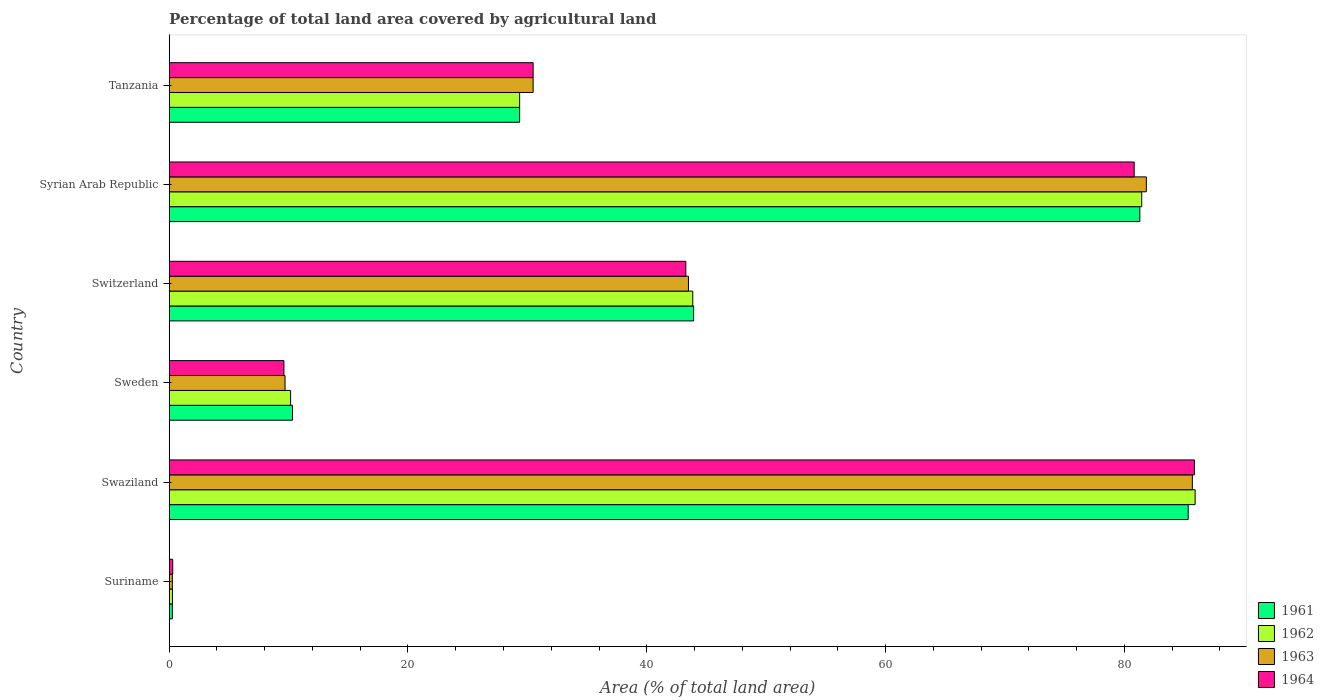How many groups of bars are there?
Make the answer very short. 6. Are the number of bars per tick equal to the number of legend labels?
Give a very brief answer. Yes. Are the number of bars on each tick of the Y-axis equal?
Keep it short and to the point. Yes. How many bars are there on the 4th tick from the bottom?
Your answer should be compact. 4. What is the label of the 6th group of bars from the top?
Make the answer very short. Suriname. In how many cases, is the number of bars for a given country not equal to the number of legend labels?
Provide a short and direct response. 0. What is the percentage of agricultural land in 1963 in Switzerland?
Provide a succinct answer. 43.49. Across all countries, what is the maximum percentage of agricultural land in 1964?
Offer a very short reply. 85.87. Across all countries, what is the minimum percentage of agricultural land in 1962?
Keep it short and to the point. 0.27. In which country was the percentage of agricultural land in 1964 maximum?
Offer a terse response. Swaziland. In which country was the percentage of agricultural land in 1963 minimum?
Give a very brief answer. Suriname. What is the total percentage of agricultural land in 1962 in the graph?
Keep it short and to the point. 251.03. What is the difference between the percentage of agricultural land in 1962 in Suriname and that in Switzerland?
Keep it short and to the point. -43.58. What is the difference between the percentage of agricultural land in 1961 in Tanzania and the percentage of agricultural land in 1964 in Swaziland?
Keep it short and to the point. -56.52. What is the average percentage of agricultural land in 1962 per country?
Provide a succinct answer. 41.84. What is the difference between the percentage of agricultural land in 1961 and percentage of agricultural land in 1963 in Syrian Arab Republic?
Your answer should be very brief. -0.54. In how many countries, is the percentage of agricultural land in 1964 greater than 60 %?
Your answer should be compact. 2. What is the ratio of the percentage of agricultural land in 1963 in Syrian Arab Republic to that in Tanzania?
Your response must be concise. 2.69. What is the difference between the highest and the second highest percentage of agricultural land in 1963?
Ensure brevity in your answer.  3.86. What is the difference between the highest and the lowest percentage of agricultural land in 1963?
Your answer should be very brief. 85.43. In how many countries, is the percentage of agricultural land in 1962 greater than the average percentage of agricultural land in 1962 taken over all countries?
Provide a succinct answer. 3. Is the sum of the percentage of agricultural land in 1964 in Suriname and Swaziland greater than the maximum percentage of agricultural land in 1961 across all countries?
Provide a succinct answer. Yes. What does the 4th bar from the bottom in Swaziland represents?
Make the answer very short. 1964. Are all the bars in the graph horizontal?
Your response must be concise. Yes. How many countries are there in the graph?
Keep it short and to the point. 6. Does the graph contain grids?
Provide a short and direct response. No. Where does the legend appear in the graph?
Make the answer very short. Bottom right. How are the legend labels stacked?
Offer a terse response. Vertical. What is the title of the graph?
Provide a succinct answer. Percentage of total land area covered by agricultural land. Does "1998" appear as one of the legend labels in the graph?
Provide a succinct answer. No. What is the label or title of the X-axis?
Your answer should be very brief. Area (% of total land area). What is the Area (% of total land area) of 1961 in Suriname?
Your response must be concise. 0.26. What is the Area (% of total land area) in 1962 in Suriname?
Offer a very short reply. 0.27. What is the Area (% of total land area) in 1963 in Suriname?
Provide a succinct answer. 0.26. What is the Area (% of total land area) in 1964 in Suriname?
Provide a short and direct response. 0.29. What is the Area (% of total land area) of 1961 in Swaziland?
Make the answer very short. 85.35. What is the Area (% of total land area) of 1962 in Swaziland?
Your answer should be compact. 85.93. What is the Area (% of total land area) in 1963 in Swaziland?
Keep it short and to the point. 85.7. What is the Area (% of total land area) in 1964 in Swaziland?
Provide a succinct answer. 85.87. What is the Area (% of total land area) in 1961 in Sweden?
Your answer should be compact. 10.33. What is the Area (% of total land area) of 1962 in Sweden?
Make the answer very short. 10.17. What is the Area (% of total land area) in 1963 in Sweden?
Offer a terse response. 9.7. What is the Area (% of total land area) in 1964 in Sweden?
Offer a very short reply. 9.61. What is the Area (% of total land area) in 1961 in Switzerland?
Your answer should be very brief. 43.93. What is the Area (% of total land area) in 1962 in Switzerland?
Your answer should be compact. 43.85. What is the Area (% of total land area) in 1963 in Switzerland?
Give a very brief answer. 43.49. What is the Area (% of total land area) of 1964 in Switzerland?
Make the answer very short. 43.27. What is the Area (% of total land area) of 1961 in Syrian Arab Republic?
Offer a very short reply. 81.3. What is the Area (% of total land area) in 1962 in Syrian Arab Republic?
Make the answer very short. 81.46. What is the Area (% of total land area) in 1963 in Syrian Arab Republic?
Give a very brief answer. 81.84. What is the Area (% of total land area) of 1964 in Syrian Arab Republic?
Your answer should be compact. 80.82. What is the Area (% of total land area) in 1961 in Tanzania?
Make the answer very short. 29.35. What is the Area (% of total land area) in 1962 in Tanzania?
Provide a short and direct response. 29.35. What is the Area (% of total land area) in 1963 in Tanzania?
Offer a very short reply. 30.48. What is the Area (% of total land area) in 1964 in Tanzania?
Provide a succinct answer. 30.48. Across all countries, what is the maximum Area (% of total land area) in 1961?
Provide a short and direct response. 85.35. Across all countries, what is the maximum Area (% of total land area) of 1962?
Provide a short and direct response. 85.93. Across all countries, what is the maximum Area (% of total land area) in 1963?
Your answer should be compact. 85.7. Across all countries, what is the maximum Area (% of total land area) of 1964?
Your answer should be compact. 85.87. Across all countries, what is the minimum Area (% of total land area) of 1961?
Your answer should be very brief. 0.26. Across all countries, what is the minimum Area (% of total land area) of 1962?
Offer a very short reply. 0.27. Across all countries, what is the minimum Area (% of total land area) of 1963?
Your response must be concise. 0.26. Across all countries, what is the minimum Area (% of total land area) of 1964?
Ensure brevity in your answer.  0.29. What is the total Area (% of total land area) of 1961 in the graph?
Provide a short and direct response. 250.51. What is the total Area (% of total land area) in 1962 in the graph?
Offer a very short reply. 251.03. What is the total Area (% of total land area) in 1963 in the graph?
Ensure brevity in your answer.  251.48. What is the total Area (% of total land area) in 1964 in the graph?
Keep it short and to the point. 250.35. What is the difference between the Area (% of total land area) of 1961 in Suriname and that in Swaziland?
Keep it short and to the point. -85.09. What is the difference between the Area (% of total land area) in 1962 in Suriname and that in Swaziland?
Offer a very short reply. -85.66. What is the difference between the Area (% of total land area) in 1963 in Suriname and that in Swaziland?
Your answer should be very brief. -85.43. What is the difference between the Area (% of total land area) in 1964 in Suriname and that in Swaziland?
Give a very brief answer. -85.58. What is the difference between the Area (% of total land area) in 1961 in Suriname and that in Sweden?
Your answer should be very brief. -10.06. What is the difference between the Area (% of total land area) in 1962 in Suriname and that in Sweden?
Your response must be concise. -9.9. What is the difference between the Area (% of total land area) of 1963 in Suriname and that in Sweden?
Keep it short and to the point. -9.44. What is the difference between the Area (% of total land area) in 1964 in Suriname and that in Sweden?
Your response must be concise. -9.31. What is the difference between the Area (% of total land area) in 1961 in Suriname and that in Switzerland?
Your answer should be compact. -43.66. What is the difference between the Area (% of total land area) in 1962 in Suriname and that in Switzerland?
Provide a short and direct response. -43.58. What is the difference between the Area (% of total land area) of 1963 in Suriname and that in Switzerland?
Your response must be concise. -43.23. What is the difference between the Area (% of total land area) of 1964 in Suriname and that in Switzerland?
Offer a very short reply. -42.98. What is the difference between the Area (% of total land area) of 1961 in Suriname and that in Syrian Arab Republic?
Keep it short and to the point. -81.04. What is the difference between the Area (% of total land area) in 1962 in Suriname and that in Syrian Arab Republic?
Your answer should be compact. -81.19. What is the difference between the Area (% of total land area) in 1963 in Suriname and that in Syrian Arab Republic?
Your answer should be compact. -81.58. What is the difference between the Area (% of total land area) in 1964 in Suriname and that in Syrian Arab Republic?
Offer a very short reply. -80.53. What is the difference between the Area (% of total land area) in 1961 in Suriname and that in Tanzania?
Offer a terse response. -29.09. What is the difference between the Area (% of total land area) of 1962 in Suriname and that in Tanzania?
Provide a succinct answer. -29.08. What is the difference between the Area (% of total land area) of 1963 in Suriname and that in Tanzania?
Your answer should be very brief. -30.22. What is the difference between the Area (% of total land area) of 1964 in Suriname and that in Tanzania?
Ensure brevity in your answer.  -30.19. What is the difference between the Area (% of total land area) in 1961 in Swaziland and that in Sweden?
Keep it short and to the point. 75.02. What is the difference between the Area (% of total land area) in 1962 in Swaziland and that in Sweden?
Provide a succinct answer. 75.76. What is the difference between the Area (% of total land area) in 1963 in Swaziland and that in Sweden?
Make the answer very short. 76. What is the difference between the Area (% of total land area) in 1964 in Swaziland and that in Sweden?
Keep it short and to the point. 76.26. What is the difference between the Area (% of total land area) in 1961 in Swaziland and that in Switzerland?
Provide a short and direct response. 41.42. What is the difference between the Area (% of total land area) of 1962 in Swaziland and that in Switzerland?
Your answer should be very brief. 42.08. What is the difference between the Area (% of total land area) of 1963 in Swaziland and that in Switzerland?
Give a very brief answer. 42.2. What is the difference between the Area (% of total land area) of 1964 in Swaziland and that in Switzerland?
Provide a short and direct response. 42.6. What is the difference between the Area (% of total land area) in 1961 in Swaziland and that in Syrian Arab Republic?
Make the answer very short. 4.05. What is the difference between the Area (% of total land area) of 1962 in Swaziland and that in Syrian Arab Republic?
Offer a very short reply. 4.47. What is the difference between the Area (% of total land area) of 1963 in Swaziland and that in Syrian Arab Republic?
Provide a succinct answer. 3.86. What is the difference between the Area (% of total land area) in 1964 in Swaziland and that in Syrian Arab Republic?
Offer a very short reply. 5.05. What is the difference between the Area (% of total land area) in 1961 in Swaziland and that in Tanzania?
Provide a short and direct response. 56. What is the difference between the Area (% of total land area) of 1962 in Swaziland and that in Tanzania?
Provide a succinct answer. 56.58. What is the difference between the Area (% of total land area) in 1963 in Swaziland and that in Tanzania?
Your answer should be very brief. 55.22. What is the difference between the Area (% of total land area) of 1964 in Swaziland and that in Tanzania?
Make the answer very short. 55.39. What is the difference between the Area (% of total land area) in 1961 in Sweden and that in Switzerland?
Your answer should be very brief. -33.6. What is the difference between the Area (% of total land area) of 1962 in Sweden and that in Switzerland?
Your response must be concise. -33.69. What is the difference between the Area (% of total land area) in 1963 in Sweden and that in Switzerland?
Provide a succinct answer. -33.79. What is the difference between the Area (% of total land area) of 1964 in Sweden and that in Switzerland?
Make the answer very short. -33.66. What is the difference between the Area (% of total land area) of 1961 in Sweden and that in Syrian Arab Republic?
Give a very brief answer. -70.97. What is the difference between the Area (% of total land area) in 1962 in Sweden and that in Syrian Arab Republic?
Your answer should be compact. -71.29. What is the difference between the Area (% of total land area) of 1963 in Sweden and that in Syrian Arab Republic?
Your response must be concise. -72.14. What is the difference between the Area (% of total land area) of 1964 in Sweden and that in Syrian Arab Republic?
Provide a short and direct response. -71.22. What is the difference between the Area (% of total land area) in 1961 in Sweden and that in Tanzania?
Your answer should be compact. -19.03. What is the difference between the Area (% of total land area) in 1962 in Sweden and that in Tanzania?
Your answer should be very brief. -19.18. What is the difference between the Area (% of total land area) in 1963 in Sweden and that in Tanzania?
Give a very brief answer. -20.78. What is the difference between the Area (% of total land area) in 1964 in Sweden and that in Tanzania?
Your response must be concise. -20.87. What is the difference between the Area (% of total land area) of 1961 in Switzerland and that in Syrian Arab Republic?
Your answer should be compact. -37.37. What is the difference between the Area (% of total land area) in 1962 in Switzerland and that in Syrian Arab Republic?
Give a very brief answer. -37.6. What is the difference between the Area (% of total land area) of 1963 in Switzerland and that in Syrian Arab Republic?
Make the answer very short. -38.35. What is the difference between the Area (% of total land area) in 1964 in Switzerland and that in Syrian Arab Republic?
Provide a short and direct response. -37.55. What is the difference between the Area (% of total land area) in 1961 in Switzerland and that in Tanzania?
Give a very brief answer. 14.57. What is the difference between the Area (% of total land area) of 1962 in Switzerland and that in Tanzania?
Offer a terse response. 14.5. What is the difference between the Area (% of total land area) in 1963 in Switzerland and that in Tanzania?
Offer a very short reply. 13.01. What is the difference between the Area (% of total land area) in 1964 in Switzerland and that in Tanzania?
Make the answer very short. 12.79. What is the difference between the Area (% of total land area) in 1961 in Syrian Arab Republic and that in Tanzania?
Your answer should be very brief. 51.95. What is the difference between the Area (% of total land area) of 1962 in Syrian Arab Republic and that in Tanzania?
Ensure brevity in your answer.  52.1. What is the difference between the Area (% of total land area) in 1963 in Syrian Arab Republic and that in Tanzania?
Provide a short and direct response. 51.36. What is the difference between the Area (% of total land area) of 1964 in Syrian Arab Republic and that in Tanzania?
Ensure brevity in your answer.  50.34. What is the difference between the Area (% of total land area) of 1961 in Suriname and the Area (% of total land area) of 1962 in Swaziland?
Give a very brief answer. -85.67. What is the difference between the Area (% of total land area) in 1961 in Suriname and the Area (% of total land area) in 1963 in Swaziland?
Your response must be concise. -85.43. What is the difference between the Area (% of total land area) in 1961 in Suriname and the Area (% of total land area) in 1964 in Swaziland?
Your answer should be very brief. -85.61. What is the difference between the Area (% of total land area) in 1962 in Suriname and the Area (% of total land area) in 1963 in Swaziland?
Offer a very short reply. -85.43. What is the difference between the Area (% of total land area) in 1962 in Suriname and the Area (% of total land area) in 1964 in Swaziland?
Provide a short and direct response. -85.6. What is the difference between the Area (% of total land area) in 1963 in Suriname and the Area (% of total land area) in 1964 in Swaziland?
Your response must be concise. -85.61. What is the difference between the Area (% of total land area) of 1961 in Suriname and the Area (% of total land area) of 1962 in Sweden?
Your answer should be very brief. -9.9. What is the difference between the Area (% of total land area) in 1961 in Suriname and the Area (% of total land area) in 1963 in Sweden?
Give a very brief answer. -9.44. What is the difference between the Area (% of total land area) in 1961 in Suriname and the Area (% of total land area) in 1964 in Sweden?
Offer a terse response. -9.35. What is the difference between the Area (% of total land area) in 1962 in Suriname and the Area (% of total land area) in 1963 in Sweden?
Make the answer very short. -9.43. What is the difference between the Area (% of total land area) in 1962 in Suriname and the Area (% of total land area) in 1964 in Sweden?
Your answer should be compact. -9.34. What is the difference between the Area (% of total land area) of 1963 in Suriname and the Area (% of total land area) of 1964 in Sweden?
Make the answer very short. -9.35. What is the difference between the Area (% of total land area) of 1961 in Suriname and the Area (% of total land area) of 1962 in Switzerland?
Provide a succinct answer. -43.59. What is the difference between the Area (% of total land area) of 1961 in Suriname and the Area (% of total land area) of 1963 in Switzerland?
Make the answer very short. -43.23. What is the difference between the Area (% of total land area) in 1961 in Suriname and the Area (% of total land area) in 1964 in Switzerland?
Your answer should be very brief. -43.01. What is the difference between the Area (% of total land area) in 1962 in Suriname and the Area (% of total land area) in 1963 in Switzerland?
Provide a succinct answer. -43.22. What is the difference between the Area (% of total land area) of 1962 in Suriname and the Area (% of total land area) of 1964 in Switzerland?
Offer a terse response. -43. What is the difference between the Area (% of total land area) in 1963 in Suriname and the Area (% of total land area) in 1964 in Switzerland?
Provide a succinct answer. -43.01. What is the difference between the Area (% of total land area) in 1961 in Suriname and the Area (% of total land area) in 1962 in Syrian Arab Republic?
Provide a succinct answer. -81.19. What is the difference between the Area (% of total land area) of 1961 in Suriname and the Area (% of total land area) of 1963 in Syrian Arab Republic?
Your answer should be very brief. -81.58. What is the difference between the Area (% of total land area) in 1961 in Suriname and the Area (% of total land area) in 1964 in Syrian Arab Republic?
Your response must be concise. -80.56. What is the difference between the Area (% of total land area) of 1962 in Suriname and the Area (% of total land area) of 1963 in Syrian Arab Republic?
Your answer should be very brief. -81.57. What is the difference between the Area (% of total land area) in 1962 in Suriname and the Area (% of total land area) in 1964 in Syrian Arab Republic?
Your answer should be very brief. -80.56. What is the difference between the Area (% of total land area) in 1963 in Suriname and the Area (% of total land area) in 1964 in Syrian Arab Republic?
Your response must be concise. -80.56. What is the difference between the Area (% of total land area) in 1961 in Suriname and the Area (% of total land area) in 1962 in Tanzania?
Provide a succinct answer. -29.09. What is the difference between the Area (% of total land area) of 1961 in Suriname and the Area (% of total land area) of 1963 in Tanzania?
Make the answer very short. -30.22. What is the difference between the Area (% of total land area) in 1961 in Suriname and the Area (% of total land area) in 1964 in Tanzania?
Give a very brief answer. -30.22. What is the difference between the Area (% of total land area) in 1962 in Suriname and the Area (% of total land area) in 1963 in Tanzania?
Offer a very short reply. -30.21. What is the difference between the Area (% of total land area) of 1962 in Suriname and the Area (% of total land area) of 1964 in Tanzania?
Keep it short and to the point. -30.21. What is the difference between the Area (% of total land area) in 1963 in Suriname and the Area (% of total land area) in 1964 in Tanzania?
Ensure brevity in your answer.  -30.22. What is the difference between the Area (% of total land area) in 1961 in Swaziland and the Area (% of total land area) in 1962 in Sweden?
Your response must be concise. 75.18. What is the difference between the Area (% of total land area) of 1961 in Swaziland and the Area (% of total land area) of 1963 in Sweden?
Keep it short and to the point. 75.65. What is the difference between the Area (% of total land area) of 1961 in Swaziland and the Area (% of total land area) of 1964 in Sweden?
Provide a succinct answer. 75.74. What is the difference between the Area (% of total land area) in 1962 in Swaziland and the Area (% of total land area) in 1963 in Sweden?
Provide a succinct answer. 76.23. What is the difference between the Area (% of total land area) of 1962 in Swaziland and the Area (% of total land area) of 1964 in Sweden?
Your answer should be very brief. 76.32. What is the difference between the Area (% of total land area) in 1963 in Swaziland and the Area (% of total land area) in 1964 in Sweden?
Your response must be concise. 76.09. What is the difference between the Area (% of total land area) of 1961 in Swaziland and the Area (% of total land area) of 1962 in Switzerland?
Your response must be concise. 41.5. What is the difference between the Area (% of total land area) in 1961 in Swaziland and the Area (% of total land area) in 1963 in Switzerland?
Make the answer very short. 41.86. What is the difference between the Area (% of total land area) of 1961 in Swaziland and the Area (% of total land area) of 1964 in Switzerland?
Make the answer very short. 42.08. What is the difference between the Area (% of total land area) of 1962 in Swaziland and the Area (% of total land area) of 1963 in Switzerland?
Your answer should be very brief. 42.44. What is the difference between the Area (% of total land area) in 1962 in Swaziland and the Area (% of total land area) in 1964 in Switzerland?
Your response must be concise. 42.66. What is the difference between the Area (% of total land area) of 1963 in Swaziland and the Area (% of total land area) of 1964 in Switzerland?
Your answer should be very brief. 42.43. What is the difference between the Area (% of total land area) in 1961 in Swaziland and the Area (% of total land area) in 1962 in Syrian Arab Republic?
Your answer should be compact. 3.89. What is the difference between the Area (% of total land area) in 1961 in Swaziland and the Area (% of total land area) in 1963 in Syrian Arab Republic?
Ensure brevity in your answer.  3.51. What is the difference between the Area (% of total land area) in 1961 in Swaziland and the Area (% of total land area) in 1964 in Syrian Arab Republic?
Provide a short and direct response. 4.52. What is the difference between the Area (% of total land area) in 1962 in Swaziland and the Area (% of total land area) in 1963 in Syrian Arab Republic?
Your response must be concise. 4.09. What is the difference between the Area (% of total land area) of 1962 in Swaziland and the Area (% of total land area) of 1964 in Syrian Arab Republic?
Keep it short and to the point. 5.11. What is the difference between the Area (% of total land area) of 1963 in Swaziland and the Area (% of total land area) of 1964 in Syrian Arab Republic?
Offer a very short reply. 4.87. What is the difference between the Area (% of total land area) in 1961 in Swaziland and the Area (% of total land area) in 1962 in Tanzania?
Make the answer very short. 56. What is the difference between the Area (% of total land area) in 1961 in Swaziland and the Area (% of total land area) in 1963 in Tanzania?
Your answer should be compact. 54.87. What is the difference between the Area (% of total land area) of 1961 in Swaziland and the Area (% of total land area) of 1964 in Tanzania?
Keep it short and to the point. 54.87. What is the difference between the Area (% of total land area) of 1962 in Swaziland and the Area (% of total land area) of 1963 in Tanzania?
Your response must be concise. 55.45. What is the difference between the Area (% of total land area) in 1962 in Swaziland and the Area (% of total land area) in 1964 in Tanzania?
Ensure brevity in your answer.  55.45. What is the difference between the Area (% of total land area) in 1963 in Swaziland and the Area (% of total land area) in 1964 in Tanzania?
Make the answer very short. 55.22. What is the difference between the Area (% of total land area) in 1961 in Sweden and the Area (% of total land area) in 1962 in Switzerland?
Keep it short and to the point. -33.53. What is the difference between the Area (% of total land area) in 1961 in Sweden and the Area (% of total land area) in 1963 in Switzerland?
Give a very brief answer. -33.17. What is the difference between the Area (% of total land area) of 1961 in Sweden and the Area (% of total land area) of 1964 in Switzerland?
Offer a very short reply. -32.95. What is the difference between the Area (% of total land area) of 1962 in Sweden and the Area (% of total land area) of 1963 in Switzerland?
Your response must be concise. -33.33. What is the difference between the Area (% of total land area) in 1962 in Sweden and the Area (% of total land area) in 1964 in Switzerland?
Keep it short and to the point. -33.1. What is the difference between the Area (% of total land area) of 1963 in Sweden and the Area (% of total land area) of 1964 in Switzerland?
Keep it short and to the point. -33.57. What is the difference between the Area (% of total land area) of 1961 in Sweden and the Area (% of total land area) of 1962 in Syrian Arab Republic?
Offer a terse response. -71.13. What is the difference between the Area (% of total land area) in 1961 in Sweden and the Area (% of total land area) in 1963 in Syrian Arab Republic?
Ensure brevity in your answer.  -71.52. What is the difference between the Area (% of total land area) of 1961 in Sweden and the Area (% of total land area) of 1964 in Syrian Arab Republic?
Provide a succinct answer. -70.5. What is the difference between the Area (% of total land area) of 1962 in Sweden and the Area (% of total land area) of 1963 in Syrian Arab Republic?
Give a very brief answer. -71.68. What is the difference between the Area (% of total land area) in 1962 in Sweden and the Area (% of total land area) in 1964 in Syrian Arab Republic?
Your answer should be compact. -70.66. What is the difference between the Area (% of total land area) of 1963 in Sweden and the Area (% of total land area) of 1964 in Syrian Arab Republic?
Your response must be concise. -71.12. What is the difference between the Area (% of total land area) of 1961 in Sweden and the Area (% of total land area) of 1962 in Tanzania?
Your answer should be very brief. -19.03. What is the difference between the Area (% of total land area) in 1961 in Sweden and the Area (% of total land area) in 1963 in Tanzania?
Give a very brief answer. -20.16. What is the difference between the Area (% of total land area) of 1961 in Sweden and the Area (% of total land area) of 1964 in Tanzania?
Provide a short and direct response. -20.16. What is the difference between the Area (% of total land area) in 1962 in Sweden and the Area (% of total land area) in 1963 in Tanzania?
Provide a succinct answer. -20.31. What is the difference between the Area (% of total land area) in 1962 in Sweden and the Area (% of total land area) in 1964 in Tanzania?
Your answer should be compact. -20.31. What is the difference between the Area (% of total land area) of 1963 in Sweden and the Area (% of total land area) of 1964 in Tanzania?
Make the answer very short. -20.78. What is the difference between the Area (% of total land area) of 1961 in Switzerland and the Area (% of total land area) of 1962 in Syrian Arab Republic?
Ensure brevity in your answer.  -37.53. What is the difference between the Area (% of total land area) of 1961 in Switzerland and the Area (% of total land area) of 1963 in Syrian Arab Republic?
Ensure brevity in your answer.  -37.92. What is the difference between the Area (% of total land area) of 1961 in Switzerland and the Area (% of total land area) of 1964 in Syrian Arab Republic?
Provide a short and direct response. -36.9. What is the difference between the Area (% of total land area) of 1962 in Switzerland and the Area (% of total land area) of 1963 in Syrian Arab Republic?
Make the answer very short. -37.99. What is the difference between the Area (% of total land area) in 1962 in Switzerland and the Area (% of total land area) in 1964 in Syrian Arab Republic?
Give a very brief answer. -36.97. What is the difference between the Area (% of total land area) in 1963 in Switzerland and the Area (% of total land area) in 1964 in Syrian Arab Republic?
Keep it short and to the point. -37.33. What is the difference between the Area (% of total land area) of 1961 in Switzerland and the Area (% of total land area) of 1962 in Tanzania?
Make the answer very short. 14.57. What is the difference between the Area (% of total land area) in 1961 in Switzerland and the Area (% of total land area) in 1963 in Tanzania?
Your response must be concise. 13.44. What is the difference between the Area (% of total land area) in 1961 in Switzerland and the Area (% of total land area) in 1964 in Tanzania?
Your answer should be compact. 13.44. What is the difference between the Area (% of total land area) in 1962 in Switzerland and the Area (% of total land area) in 1963 in Tanzania?
Give a very brief answer. 13.37. What is the difference between the Area (% of total land area) of 1962 in Switzerland and the Area (% of total land area) of 1964 in Tanzania?
Provide a short and direct response. 13.37. What is the difference between the Area (% of total land area) in 1963 in Switzerland and the Area (% of total land area) in 1964 in Tanzania?
Your answer should be compact. 13.01. What is the difference between the Area (% of total land area) in 1961 in Syrian Arab Republic and the Area (% of total land area) in 1962 in Tanzania?
Offer a very short reply. 51.95. What is the difference between the Area (% of total land area) of 1961 in Syrian Arab Republic and the Area (% of total land area) of 1963 in Tanzania?
Your answer should be compact. 50.82. What is the difference between the Area (% of total land area) of 1961 in Syrian Arab Republic and the Area (% of total land area) of 1964 in Tanzania?
Your response must be concise. 50.82. What is the difference between the Area (% of total land area) of 1962 in Syrian Arab Republic and the Area (% of total land area) of 1963 in Tanzania?
Your answer should be very brief. 50.98. What is the difference between the Area (% of total land area) of 1962 in Syrian Arab Republic and the Area (% of total land area) of 1964 in Tanzania?
Ensure brevity in your answer.  50.98. What is the difference between the Area (% of total land area) in 1963 in Syrian Arab Republic and the Area (% of total land area) in 1964 in Tanzania?
Give a very brief answer. 51.36. What is the average Area (% of total land area) of 1961 per country?
Offer a terse response. 41.75. What is the average Area (% of total land area) of 1962 per country?
Provide a succinct answer. 41.84. What is the average Area (% of total land area) of 1963 per country?
Offer a very short reply. 41.91. What is the average Area (% of total land area) in 1964 per country?
Offer a very short reply. 41.73. What is the difference between the Area (% of total land area) in 1961 and Area (% of total land area) in 1962 in Suriname?
Your answer should be compact. -0.01. What is the difference between the Area (% of total land area) in 1961 and Area (% of total land area) in 1963 in Suriname?
Offer a very short reply. 0. What is the difference between the Area (% of total land area) of 1961 and Area (% of total land area) of 1964 in Suriname?
Offer a terse response. -0.03. What is the difference between the Area (% of total land area) of 1962 and Area (% of total land area) of 1963 in Suriname?
Your answer should be very brief. 0.01. What is the difference between the Area (% of total land area) in 1962 and Area (% of total land area) in 1964 in Suriname?
Provide a short and direct response. -0.03. What is the difference between the Area (% of total land area) in 1963 and Area (% of total land area) in 1964 in Suriname?
Offer a very short reply. -0.03. What is the difference between the Area (% of total land area) of 1961 and Area (% of total land area) of 1962 in Swaziland?
Make the answer very short. -0.58. What is the difference between the Area (% of total land area) in 1961 and Area (% of total land area) in 1963 in Swaziland?
Provide a short and direct response. -0.35. What is the difference between the Area (% of total land area) of 1961 and Area (% of total land area) of 1964 in Swaziland?
Make the answer very short. -0.52. What is the difference between the Area (% of total land area) of 1962 and Area (% of total land area) of 1963 in Swaziland?
Keep it short and to the point. 0.23. What is the difference between the Area (% of total land area) in 1962 and Area (% of total land area) in 1964 in Swaziland?
Ensure brevity in your answer.  0.06. What is the difference between the Area (% of total land area) of 1963 and Area (% of total land area) of 1964 in Swaziland?
Ensure brevity in your answer.  -0.17. What is the difference between the Area (% of total land area) of 1961 and Area (% of total land area) of 1962 in Sweden?
Ensure brevity in your answer.  0.16. What is the difference between the Area (% of total land area) in 1961 and Area (% of total land area) in 1963 in Sweden?
Offer a terse response. 0.62. What is the difference between the Area (% of total land area) of 1961 and Area (% of total land area) of 1964 in Sweden?
Your response must be concise. 0.72. What is the difference between the Area (% of total land area) in 1962 and Area (% of total land area) in 1963 in Sweden?
Your answer should be compact. 0.47. What is the difference between the Area (% of total land area) of 1962 and Area (% of total land area) of 1964 in Sweden?
Ensure brevity in your answer.  0.56. What is the difference between the Area (% of total land area) in 1963 and Area (% of total land area) in 1964 in Sweden?
Make the answer very short. 0.09. What is the difference between the Area (% of total land area) of 1961 and Area (% of total land area) of 1962 in Switzerland?
Make the answer very short. 0.07. What is the difference between the Area (% of total land area) in 1961 and Area (% of total land area) in 1963 in Switzerland?
Offer a terse response. 0.43. What is the difference between the Area (% of total land area) of 1961 and Area (% of total land area) of 1964 in Switzerland?
Provide a short and direct response. 0.66. What is the difference between the Area (% of total land area) of 1962 and Area (% of total land area) of 1963 in Switzerland?
Your answer should be very brief. 0.36. What is the difference between the Area (% of total land area) in 1962 and Area (% of total land area) in 1964 in Switzerland?
Your answer should be compact. 0.58. What is the difference between the Area (% of total land area) in 1963 and Area (% of total land area) in 1964 in Switzerland?
Offer a very short reply. 0.22. What is the difference between the Area (% of total land area) in 1961 and Area (% of total land area) in 1962 in Syrian Arab Republic?
Make the answer very short. -0.16. What is the difference between the Area (% of total land area) in 1961 and Area (% of total land area) in 1963 in Syrian Arab Republic?
Give a very brief answer. -0.54. What is the difference between the Area (% of total land area) in 1961 and Area (% of total land area) in 1964 in Syrian Arab Republic?
Ensure brevity in your answer.  0.47. What is the difference between the Area (% of total land area) in 1962 and Area (% of total land area) in 1963 in Syrian Arab Republic?
Ensure brevity in your answer.  -0.39. What is the difference between the Area (% of total land area) of 1962 and Area (% of total land area) of 1964 in Syrian Arab Republic?
Provide a succinct answer. 0.63. What is the difference between the Area (% of total land area) of 1963 and Area (% of total land area) of 1964 in Syrian Arab Republic?
Provide a short and direct response. 1.02. What is the difference between the Area (% of total land area) of 1961 and Area (% of total land area) of 1963 in Tanzania?
Ensure brevity in your answer.  -1.13. What is the difference between the Area (% of total land area) in 1961 and Area (% of total land area) in 1964 in Tanzania?
Offer a terse response. -1.13. What is the difference between the Area (% of total land area) in 1962 and Area (% of total land area) in 1963 in Tanzania?
Your answer should be compact. -1.13. What is the difference between the Area (% of total land area) of 1962 and Area (% of total land area) of 1964 in Tanzania?
Your answer should be compact. -1.13. What is the difference between the Area (% of total land area) in 1963 and Area (% of total land area) in 1964 in Tanzania?
Give a very brief answer. 0. What is the ratio of the Area (% of total land area) in 1961 in Suriname to that in Swaziland?
Offer a very short reply. 0. What is the ratio of the Area (% of total land area) of 1962 in Suriname to that in Swaziland?
Offer a very short reply. 0. What is the ratio of the Area (% of total land area) in 1963 in Suriname to that in Swaziland?
Keep it short and to the point. 0. What is the ratio of the Area (% of total land area) in 1964 in Suriname to that in Swaziland?
Make the answer very short. 0. What is the ratio of the Area (% of total land area) of 1961 in Suriname to that in Sweden?
Your answer should be compact. 0.03. What is the ratio of the Area (% of total land area) in 1962 in Suriname to that in Sweden?
Ensure brevity in your answer.  0.03. What is the ratio of the Area (% of total land area) in 1963 in Suriname to that in Sweden?
Offer a very short reply. 0.03. What is the ratio of the Area (% of total land area) in 1964 in Suriname to that in Sweden?
Your answer should be very brief. 0.03. What is the ratio of the Area (% of total land area) in 1961 in Suriname to that in Switzerland?
Ensure brevity in your answer.  0.01. What is the ratio of the Area (% of total land area) of 1962 in Suriname to that in Switzerland?
Your answer should be compact. 0.01. What is the ratio of the Area (% of total land area) of 1963 in Suriname to that in Switzerland?
Your response must be concise. 0.01. What is the ratio of the Area (% of total land area) of 1964 in Suriname to that in Switzerland?
Offer a very short reply. 0.01. What is the ratio of the Area (% of total land area) in 1961 in Suriname to that in Syrian Arab Republic?
Make the answer very short. 0. What is the ratio of the Area (% of total land area) of 1962 in Suriname to that in Syrian Arab Republic?
Keep it short and to the point. 0. What is the ratio of the Area (% of total land area) in 1963 in Suriname to that in Syrian Arab Republic?
Make the answer very short. 0. What is the ratio of the Area (% of total land area) in 1964 in Suriname to that in Syrian Arab Republic?
Provide a short and direct response. 0. What is the ratio of the Area (% of total land area) in 1961 in Suriname to that in Tanzania?
Your answer should be very brief. 0.01. What is the ratio of the Area (% of total land area) in 1962 in Suriname to that in Tanzania?
Ensure brevity in your answer.  0.01. What is the ratio of the Area (% of total land area) of 1963 in Suriname to that in Tanzania?
Provide a short and direct response. 0.01. What is the ratio of the Area (% of total land area) of 1964 in Suriname to that in Tanzania?
Ensure brevity in your answer.  0.01. What is the ratio of the Area (% of total land area) in 1961 in Swaziland to that in Sweden?
Offer a terse response. 8.27. What is the ratio of the Area (% of total land area) in 1962 in Swaziland to that in Sweden?
Provide a short and direct response. 8.45. What is the ratio of the Area (% of total land area) of 1963 in Swaziland to that in Sweden?
Offer a very short reply. 8.83. What is the ratio of the Area (% of total land area) of 1964 in Swaziland to that in Sweden?
Ensure brevity in your answer.  8.94. What is the ratio of the Area (% of total land area) of 1961 in Swaziland to that in Switzerland?
Provide a short and direct response. 1.94. What is the ratio of the Area (% of total land area) of 1962 in Swaziland to that in Switzerland?
Give a very brief answer. 1.96. What is the ratio of the Area (% of total land area) in 1963 in Swaziland to that in Switzerland?
Make the answer very short. 1.97. What is the ratio of the Area (% of total land area) of 1964 in Swaziland to that in Switzerland?
Ensure brevity in your answer.  1.98. What is the ratio of the Area (% of total land area) in 1961 in Swaziland to that in Syrian Arab Republic?
Offer a very short reply. 1.05. What is the ratio of the Area (% of total land area) of 1962 in Swaziland to that in Syrian Arab Republic?
Your answer should be compact. 1.05. What is the ratio of the Area (% of total land area) of 1963 in Swaziland to that in Syrian Arab Republic?
Give a very brief answer. 1.05. What is the ratio of the Area (% of total land area) of 1964 in Swaziland to that in Syrian Arab Republic?
Make the answer very short. 1.06. What is the ratio of the Area (% of total land area) in 1961 in Swaziland to that in Tanzania?
Give a very brief answer. 2.91. What is the ratio of the Area (% of total land area) in 1962 in Swaziland to that in Tanzania?
Offer a very short reply. 2.93. What is the ratio of the Area (% of total land area) of 1963 in Swaziland to that in Tanzania?
Ensure brevity in your answer.  2.81. What is the ratio of the Area (% of total land area) of 1964 in Swaziland to that in Tanzania?
Ensure brevity in your answer.  2.82. What is the ratio of the Area (% of total land area) of 1961 in Sweden to that in Switzerland?
Make the answer very short. 0.24. What is the ratio of the Area (% of total land area) in 1962 in Sweden to that in Switzerland?
Your answer should be compact. 0.23. What is the ratio of the Area (% of total land area) in 1963 in Sweden to that in Switzerland?
Offer a terse response. 0.22. What is the ratio of the Area (% of total land area) in 1964 in Sweden to that in Switzerland?
Provide a short and direct response. 0.22. What is the ratio of the Area (% of total land area) of 1961 in Sweden to that in Syrian Arab Republic?
Offer a very short reply. 0.13. What is the ratio of the Area (% of total land area) in 1962 in Sweden to that in Syrian Arab Republic?
Make the answer very short. 0.12. What is the ratio of the Area (% of total land area) in 1963 in Sweden to that in Syrian Arab Republic?
Provide a succinct answer. 0.12. What is the ratio of the Area (% of total land area) in 1964 in Sweden to that in Syrian Arab Republic?
Your response must be concise. 0.12. What is the ratio of the Area (% of total land area) in 1961 in Sweden to that in Tanzania?
Your response must be concise. 0.35. What is the ratio of the Area (% of total land area) of 1962 in Sweden to that in Tanzania?
Provide a succinct answer. 0.35. What is the ratio of the Area (% of total land area) in 1963 in Sweden to that in Tanzania?
Provide a short and direct response. 0.32. What is the ratio of the Area (% of total land area) of 1964 in Sweden to that in Tanzania?
Your answer should be compact. 0.32. What is the ratio of the Area (% of total land area) in 1961 in Switzerland to that in Syrian Arab Republic?
Keep it short and to the point. 0.54. What is the ratio of the Area (% of total land area) of 1962 in Switzerland to that in Syrian Arab Republic?
Your response must be concise. 0.54. What is the ratio of the Area (% of total land area) of 1963 in Switzerland to that in Syrian Arab Republic?
Provide a succinct answer. 0.53. What is the ratio of the Area (% of total land area) of 1964 in Switzerland to that in Syrian Arab Republic?
Offer a terse response. 0.54. What is the ratio of the Area (% of total land area) in 1961 in Switzerland to that in Tanzania?
Make the answer very short. 1.5. What is the ratio of the Area (% of total land area) of 1962 in Switzerland to that in Tanzania?
Provide a short and direct response. 1.49. What is the ratio of the Area (% of total land area) of 1963 in Switzerland to that in Tanzania?
Keep it short and to the point. 1.43. What is the ratio of the Area (% of total land area) of 1964 in Switzerland to that in Tanzania?
Your response must be concise. 1.42. What is the ratio of the Area (% of total land area) in 1961 in Syrian Arab Republic to that in Tanzania?
Provide a short and direct response. 2.77. What is the ratio of the Area (% of total land area) of 1962 in Syrian Arab Republic to that in Tanzania?
Your response must be concise. 2.78. What is the ratio of the Area (% of total land area) in 1963 in Syrian Arab Republic to that in Tanzania?
Your response must be concise. 2.69. What is the ratio of the Area (% of total land area) of 1964 in Syrian Arab Republic to that in Tanzania?
Your answer should be compact. 2.65. What is the difference between the highest and the second highest Area (% of total land area) in 1961?
Your answer should be very brief. 4.05. What is the difference between the highest and the second highest Area (% of total land area) of 1962?
Provide a succinct answer. 4.47. What is the difference between the highest and the second highest Area (% of total land area) of 1963?
Provide a short and direct response. 3.86. What is the difference between the highest and the second highest Area (% of total land area) of 1964?
Make the answer very short. 5.05. What is the difference between the highest and the lowest Area (% of total land area) of 1961?
Keep it short and to the point. 85.09. What is the difference between the highest and the lowest Area (% of total land area) of 1962?
Provide a succinct answer. 85.66. What is the difference between the highest and the lowest Area (% of total land area) in 1963?
Your response must be concise. 85.43. What is the difference between the highest and the lowest Area (% of total land area) of 1964?
Offer a very short reply. 85.58. 